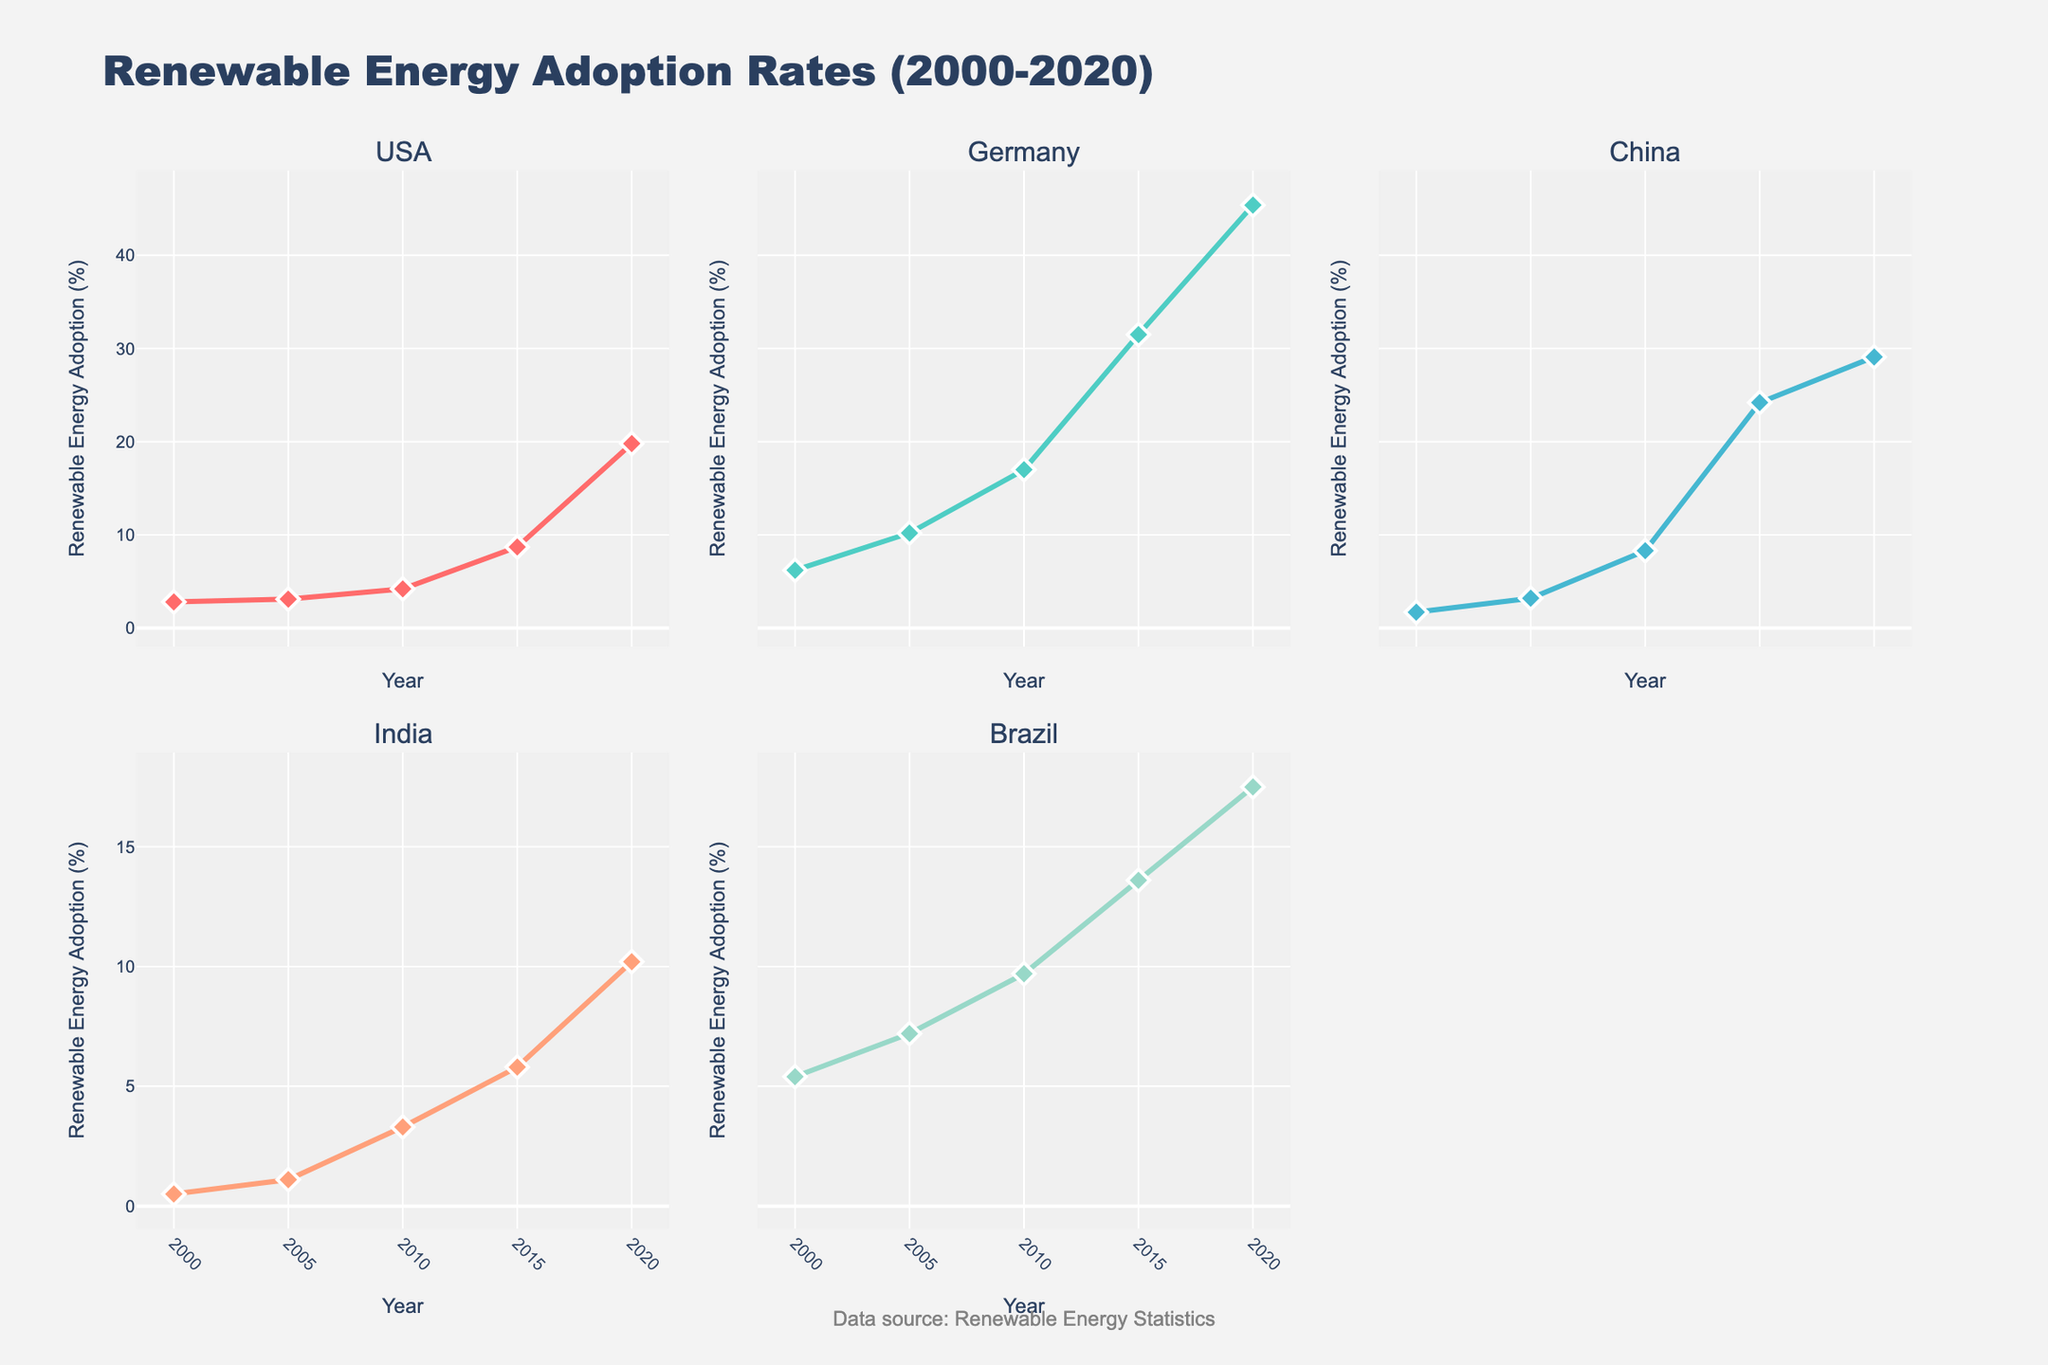What is the title of the figure? The title of the figure is written at the top, centered. It is "Renewable Energy Adoption Rates (2000-2020)".
Answer: Renewable Energy Adoption Rates (2000-2020) How many subplots are there? Counting the number of distinct areas containing graphs in the figure, you find there are six subplots.
Answer: Six Which country had the highest renewable energy adoption rate in 2000? By looking at the markers or the line for the year 2000 in each subplot, the country with the highest point is Germany with 6.2%.
Answer: Germany Between which years did the USA see the most significant increase in renewable energy adoption? Examining the USA subplot, the largest jump occurs between 2015 and 2020, going from 8.7% to 19.8%. Calculate the difference: 19.8 - 8.7 = 11.1.
Answer: 2015 to 2020 What is the trend of renewable energy adoption for India between 2000 and 2020? Following the markers for India in the subplot, you see that it steadily climbs from 0.5% in 2000 to 10.2% in 2020, showing a consistent upward trend.
Answer: Consistently upward Compare the renewable energy adoption rates of Germany and Brazil in 2020. Which country had a higher rate and by how much? From the subplots for Germany and Brazil in the year 2020, Germany's rate is 45.4% and Brazil's is 17.5%. The difference is 45.4 - 17.5 = 27.9. Hence, Germany's rate is higher by 27.9%.
Answer: Germany by 27.9% Which country had the least increase in renewable energy adoption rates from 2000 to 2020? Calculate the increase for each country: USA (19.8-2.8=17), Germany (45.4-6.2=39.2), China (29.1-1.7=27.4), India (10.2-0.5=9.7), Brazil (17.5-5.4=12.1). India had the smallest increase: 9.7.
Answer: India What is the yearly average of renewable energy adoption rates for China from 2000 to 2020? Add China's rates for each year and divide by the number of years: (1.7+3.2+8.3+24.2+29.1)/5 = 66.5/5 = 13.3%.
Answer: 13.3% What can be deduced about Brazil's renewable energy adoption from 2000 to 2005? Observing the subplot for Brazil, the adoption rate rises from 5.4% in 2000 to 7.2% in 2005, showing a modest increase of 1.8%.
Answer: Modest increase Which country showed a more dramatic increase in renewable energy adoption between 2010 and 2015: Germany or China? Examining Germany and China's subplots, Germany's rate went from 17.0% in 2010 to 31.5% in 2015 (increase of 14.5), while China's went from 8.3% to 24.2% (increase of 15.9). China had the larger increase by 1.4.
Answer: China 